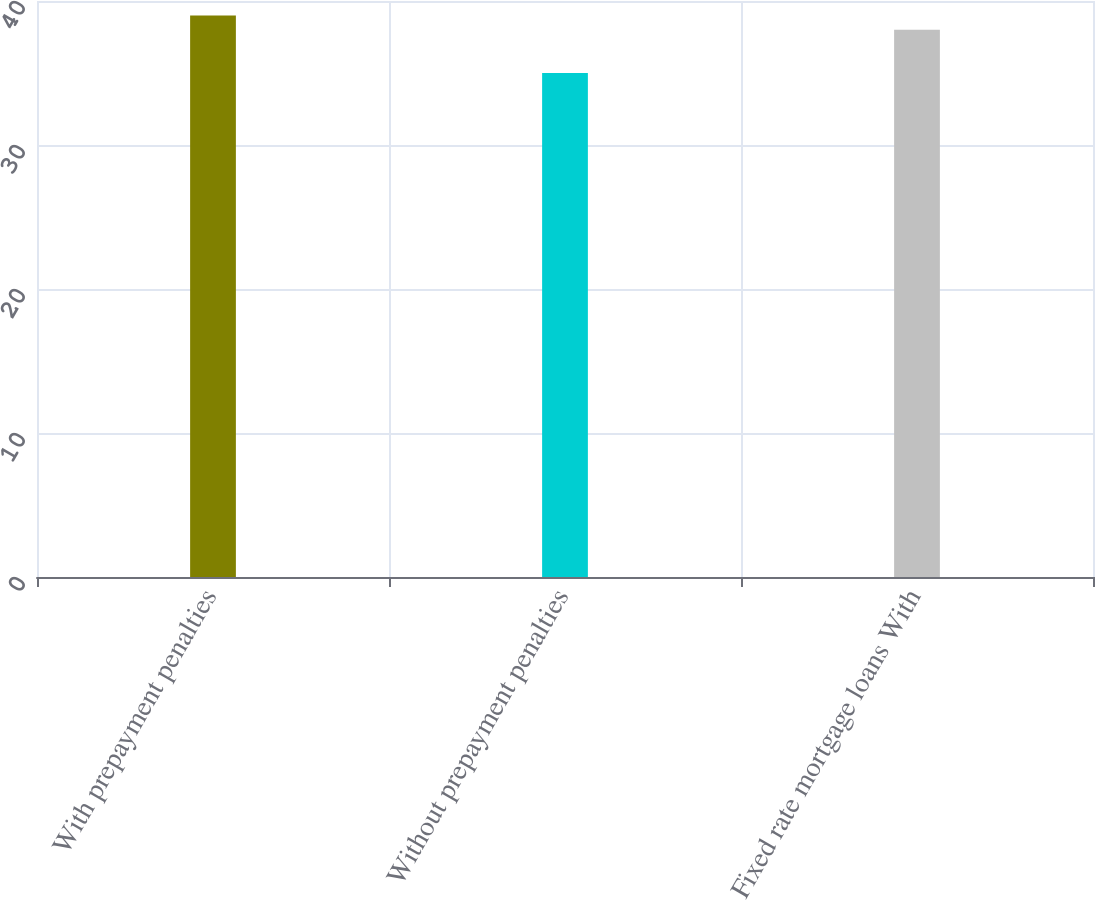Convert chart to OTSL. <chart><loc_0><loc_0><loc_500><loc_500><bar_chart><fcel>With prepayment penalties<fcel>Without prepayment penalties<fcel>Fixed rate mortgage loans With<nl><fcel>39<fcel>35<fcel>38<nl></chart> 